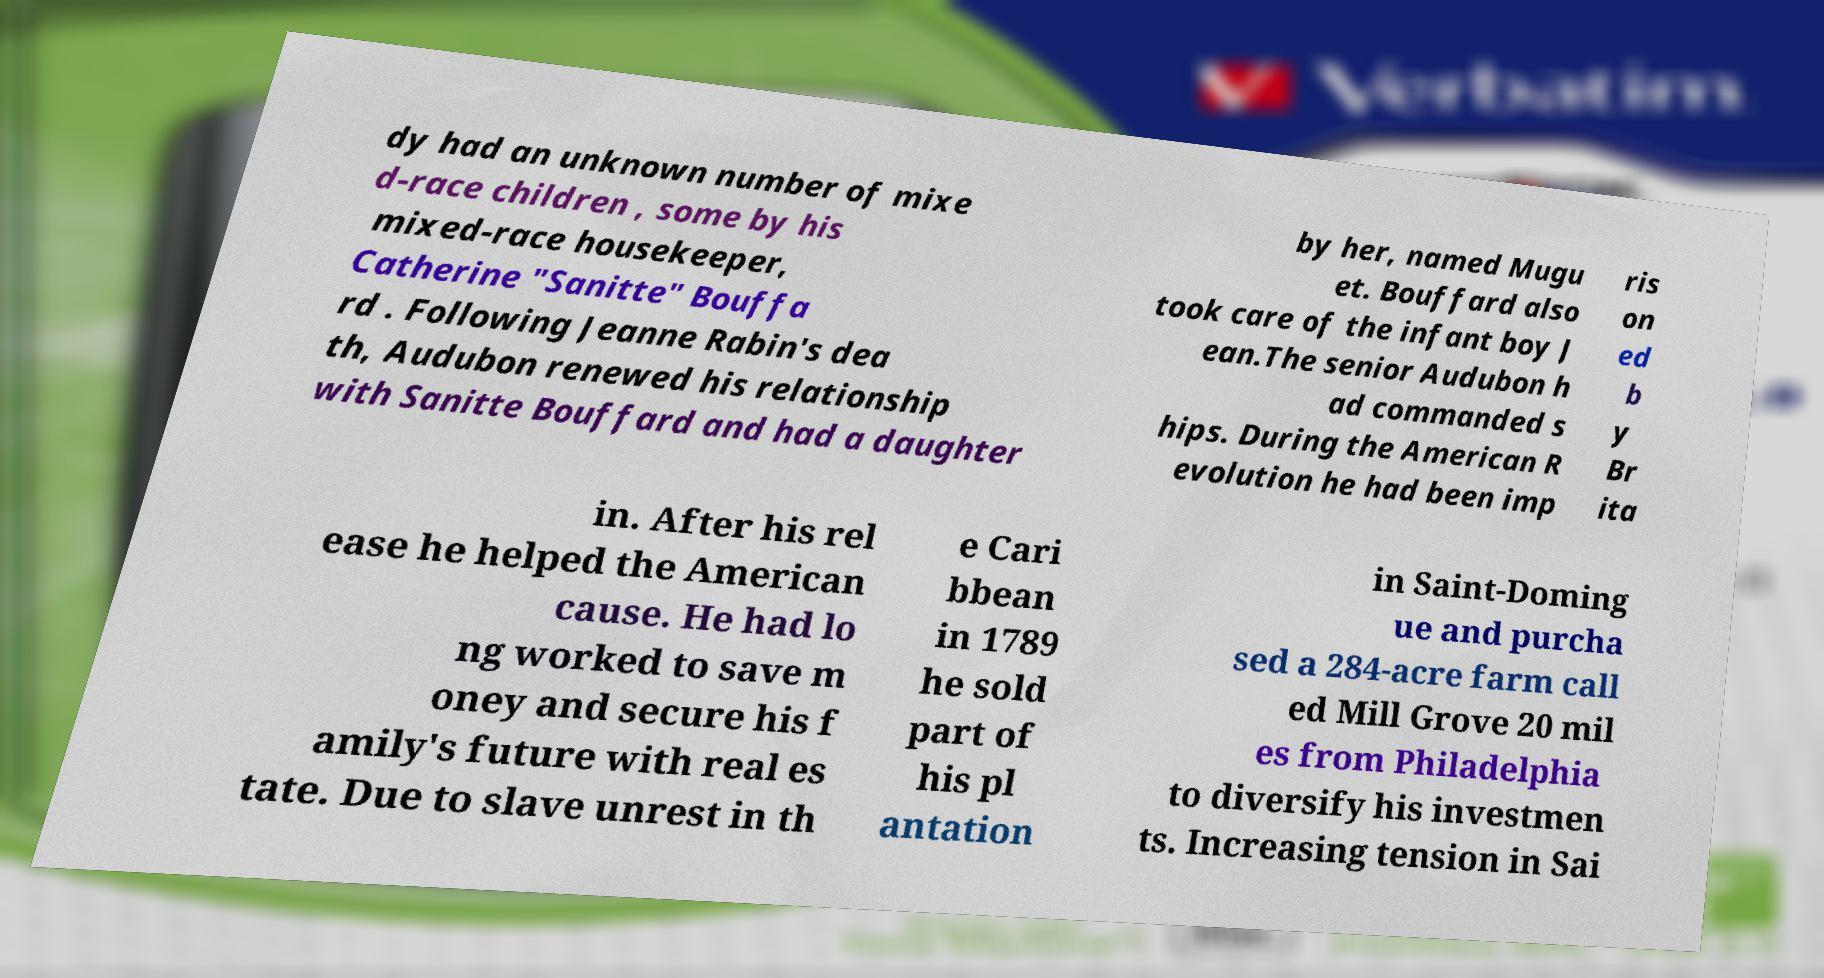Please read and relay the text visible in this image. What does it say? dy had an unknown number of mixe d-race children , some by his mixed-race housekeeper, Catherine "Sanitte" Bouffa rd . Following Jeanne Rabin's dea th, Audubon renewed his relationship with Sanitte Bouffard and had a daughter by her, named Mugu et. Bouffard also took care of the infant boy J ean.The senior Audubon h ad commanded s hips. During the American R evolution he had been imp ris on ed b y Br ita in. After his rel ease he helped the American cause. He had lo ng worked to save m oney and secure his f amily's future with real es tate. Due to slave unrest in th e Cari bbean in 1789 he sold part of his pl antation in Saint-Doming ue and purcha sed a 284-acre farm call ed Mill Grove 20 mil es from Philadelphia to diversify his investmen ts. Increasing tension in Sai 